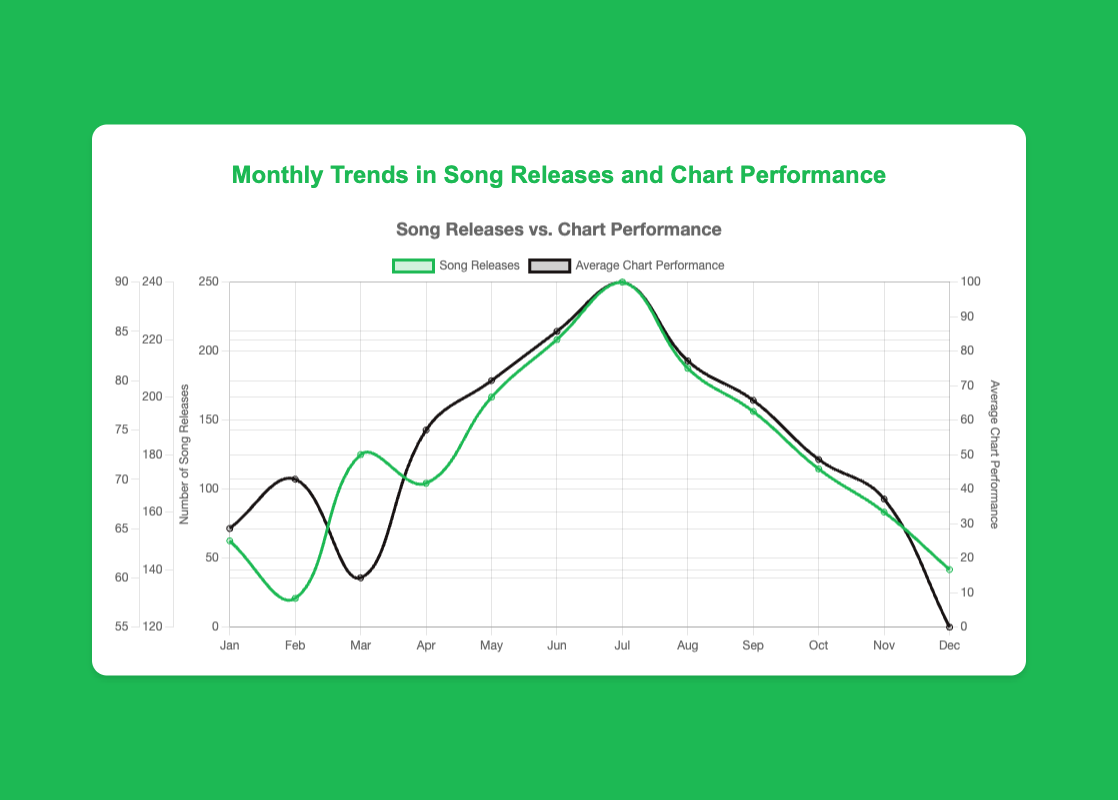Which month has the highest number of song releases? Looking at the first dataset, "Song Releases", the peak value is 240, which occurs in July.
Answer: July How does the average chart performance in June compare to December? June's average chart performance is 85, while in December, it is 55. Comparing these, June's performance is significantly higher.
Answer: June is higher What is the overall trend observed in the number of song releases from January to December? Observing the plot, there is a general upward trend in song releases from January (150) to a peak in July (240), followed by a gradual decline towards December (140).
Answer: Uptrend then downtrend Which month shows the steepest decline in average chart performance? By examining the "Average Chart Performance" data, the performance drops from 82 in August to 78 in September, which is a distinct decline.
Answer: August to September Are there any months where both the number of song releases and chart performance are increasing simultaneously? Comparing the two datasets, from June (220 releases, 85 performance) to July (240 releases, 90 performance), both metrics increase.
Answer: June to July What is the average number of song releases in the first half of the year? Summing the song releases from January to June (150+130+180+170+200+220) gives 1050. Dividing by 6 months, the average is 1050/6.
Answer: 175 Which month has the lowest chart performance? Based on the data, "Average Chart Performance" is the lowest in December at 55.
Answer: December How does the number of song releases relate to average chart performance in August? In August, there are 210 song releases and the average chart performance is 82; both are relatively high, indicating a possible positive relationship.
Answer: Positive relationship Calculate the difference in song releases between March and May. March has 180 releases and May has 200 releases. The difference is 200 - 180.
Answer: 20 In which month does the chart performance show the sharpest increase? Examining "Average Chart Performance", the sharpest increase is between March (60) to April (75), which is an increase of 15.
Answer: March to April 